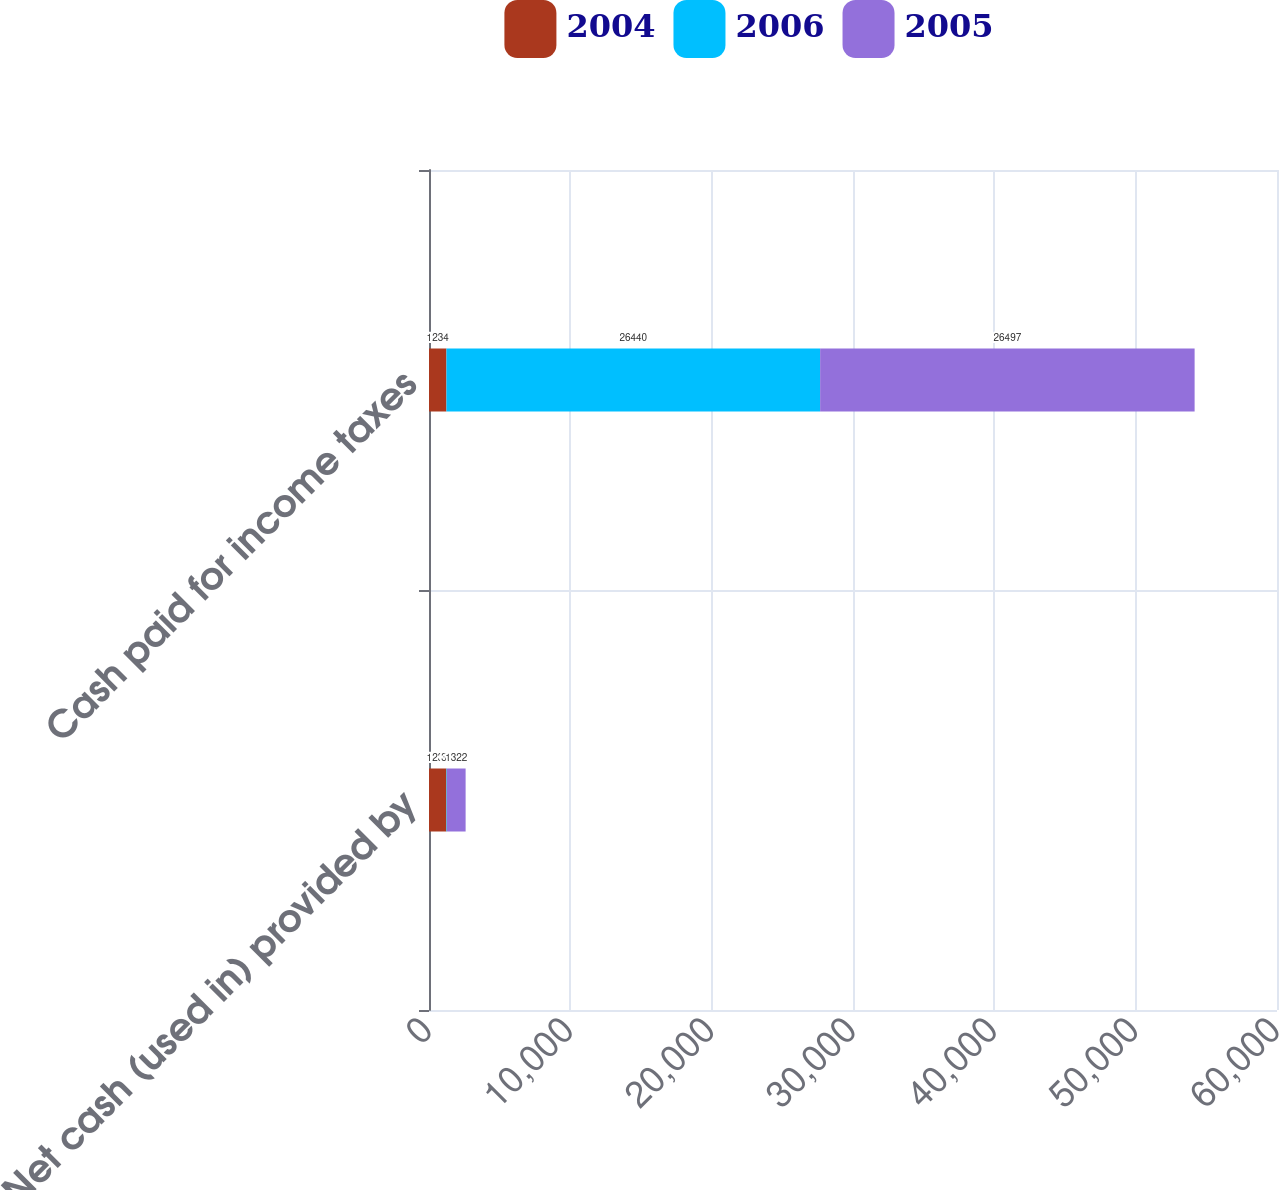<chart> <loc_0><loc_0><loc_500><loc_500><stacked_bar_chart><ecel><fcel>Net cash (used in) provided by<fcel>Cash paid for income taxes<nl><fcel>2004<fcel>1234<fcel>1234<nl><fcel>2006<fcel>35<fcel>26440<nl><fcel>2005<fcel>1322<fcel>26497<nl></chart> 